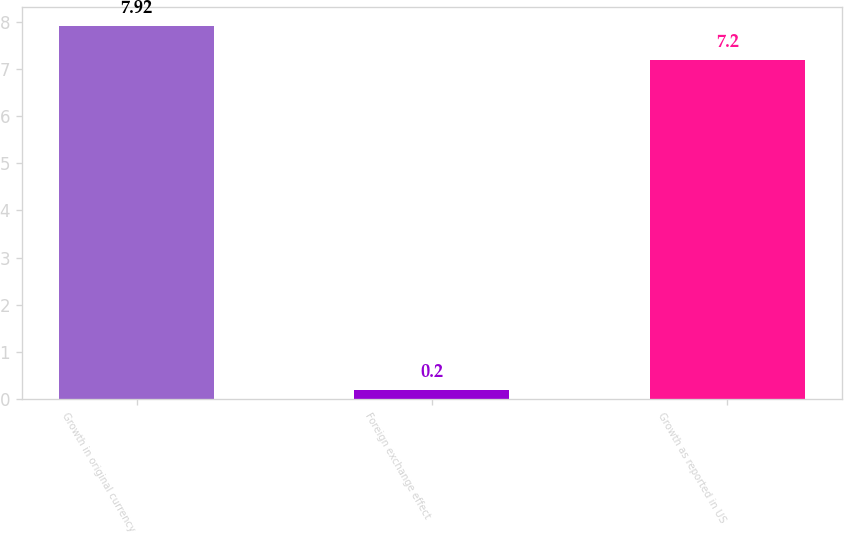Convert chart. <chart><loc_0><loc_0><loc_500><loc_500><bar_chart><fcel>Growth in original currency<fcel>Foreign exchange effect<fcel>Growth as reported in US<nl><fcel>7.92<fcel>0.2<fcel>7.2<nl></chart> 